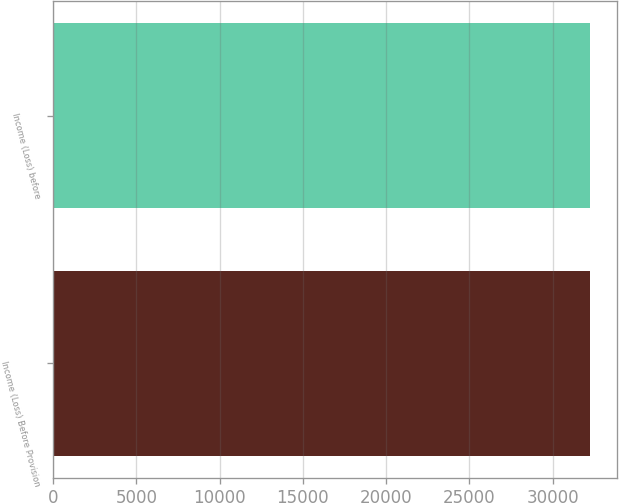Convert chart to OTSL. <chart><loc_0><loc_0><loc_500><loc_500><bar_chart><fcel>Income (Loss) Before Provision<fcel>Income (Loss) before<nl><fcel>32238<fcel>32238.1<nl></chart> 